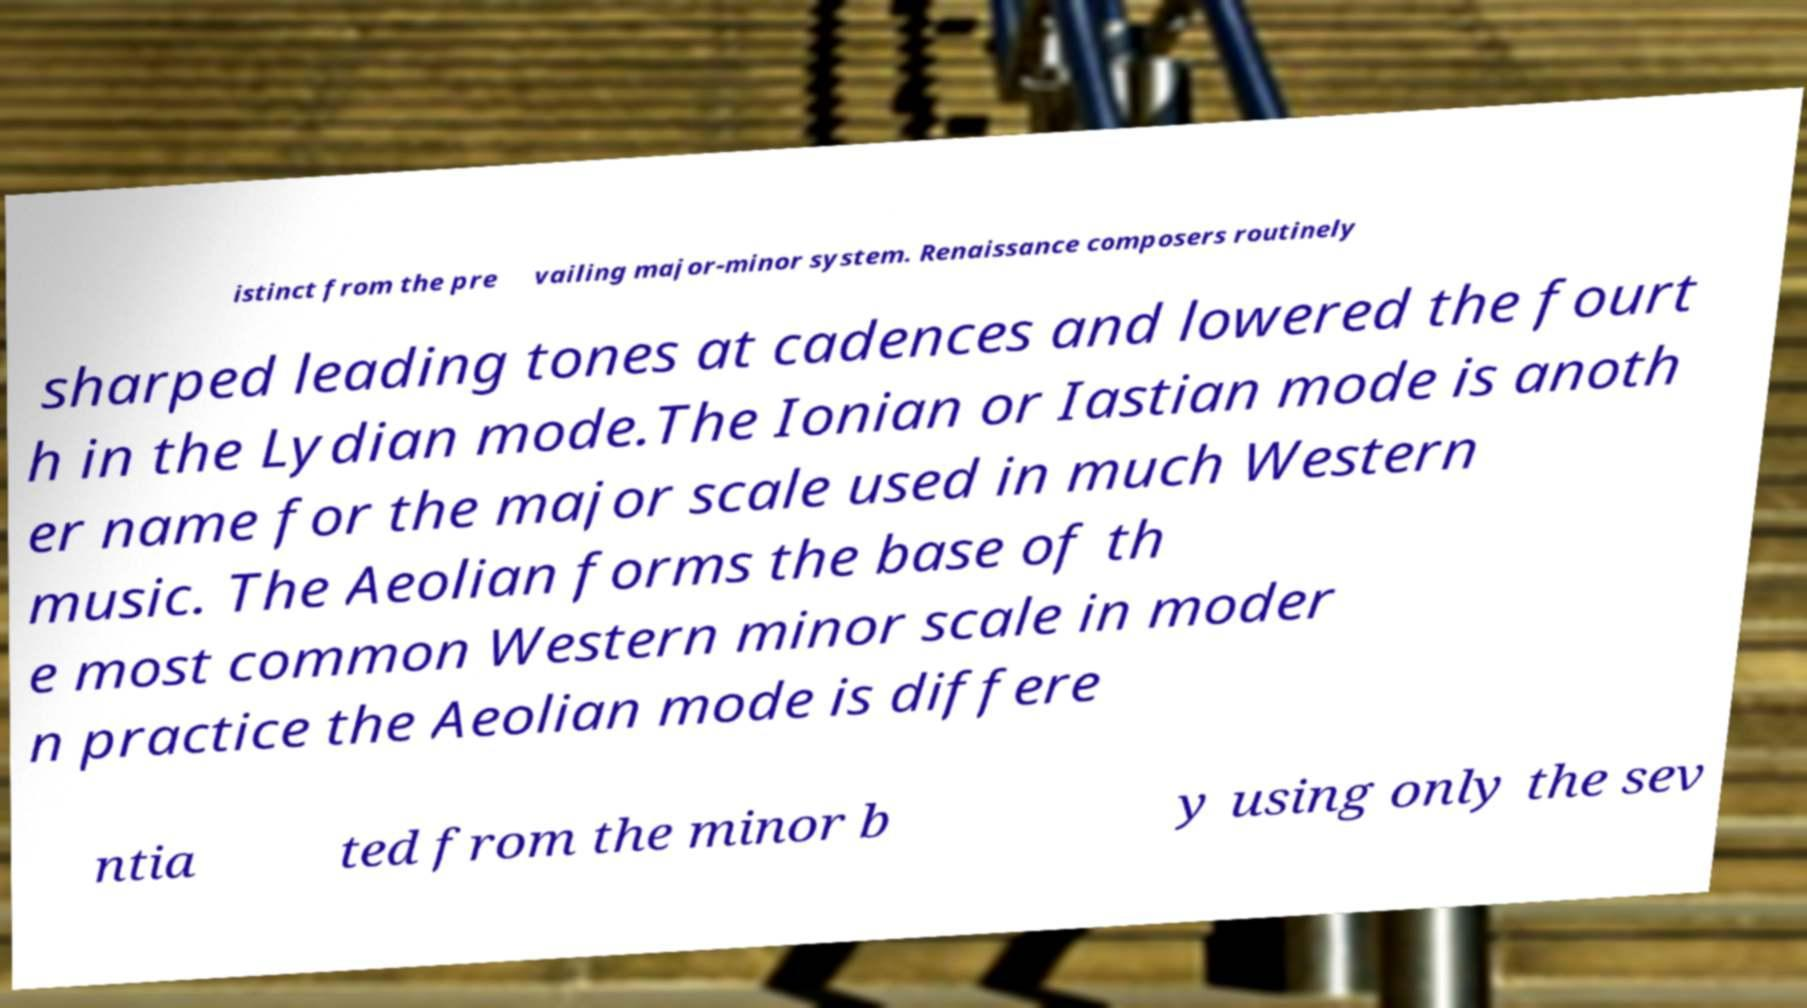Please read and relay the text visible in this image. What does it say? istinct from the pre vailing major-minor system. Renaissance composers routinely sharped leading tones at cadences and lowered the fourt h in the Lydian mode.The Ionian or Iastian mode is anoth er name for the major scale used in much Western music. The Aeolian forms the base of th e most common Western minor scale in moder n practice the Aeolian mode is differe ntia ted from the minor b y using only the sev 